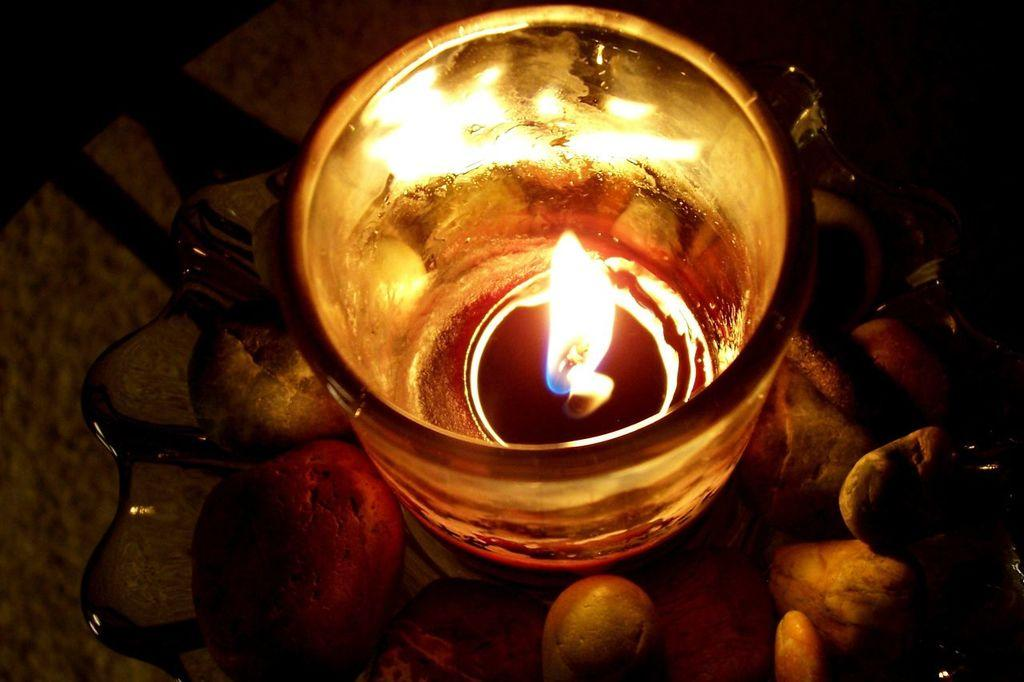What type of table is in the image? There is a glass table in the image. What is on top of the table? There is a bowl and a glass on the table. What is inside the bowl? The bowl contains stones. What is inside the glass? The glass contains a candle with light. What type of hall can be seen in the image? There is no hall present in the image; it features a glass table with a bowl, stones, a glass, and a candle with light. How many bananas are on the table in the image? There are no bananas present in the image. 